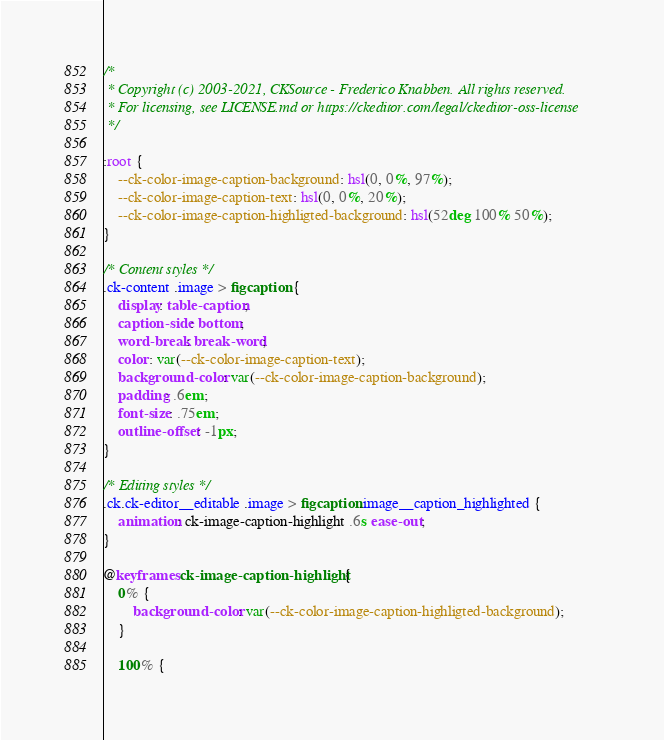<code> <loc_0><loc_0><loc_500><loc_500><_CSS_>/*
 * Copyright (c) 2003-2021, CKSource - Frederico Knabben. All rights reserved.
 * For licensing, see LICENSE.md or https://ckeditor.com/legal/ckeditor-oss-license
 */

:root {
	--ck-color-image-caption-background: hsl(0, 0%, 97%);
	--ck-color-image-caption-text: hsl(0, 0%, 20%);
	--ck-color-image-caption-highligted-background: hsl(52deg 100% 50%);
}

/* Content styles */
.ck-content .image > figcaption {
	display: table-caption;
	caption-side: bottom;
	word-break: break-word;
	color: var(--ck-color-image-caption-text);
	background-color: var(--ck-color-image-caption-background);
	padding: .6em;
	font-size: .75em;
	outline-offset: -1px;
}

/* Editing styles */
.ck.ck-editor__editable .image > figcaption.image__caption_highlighted {
	animation: ck-image-caption-highlight .6s ease-out;
}

@keyframes ck-image-caption-highlight {
	0% {
		background-color: var(--ck-color-image-caption-highligted-background);
	}

	100% {</code> 